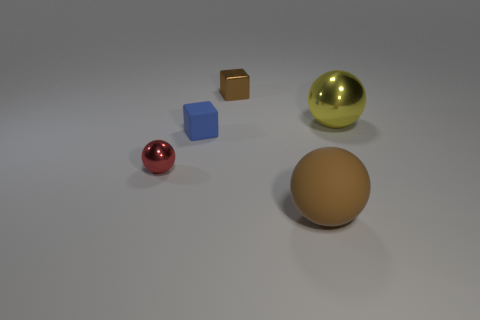Could you guess the time of day or the setting where this scene is taking place? It's difficult to determine the exact time of day or setting as the image seems to be a digitally rendered scene. There's no context of natural light or environment that would indicate a specific time of day. The uniform background and the controlled lighting suggest it's in an artificial, possibly indoor, setting designed to showcase the objects without external influence. 